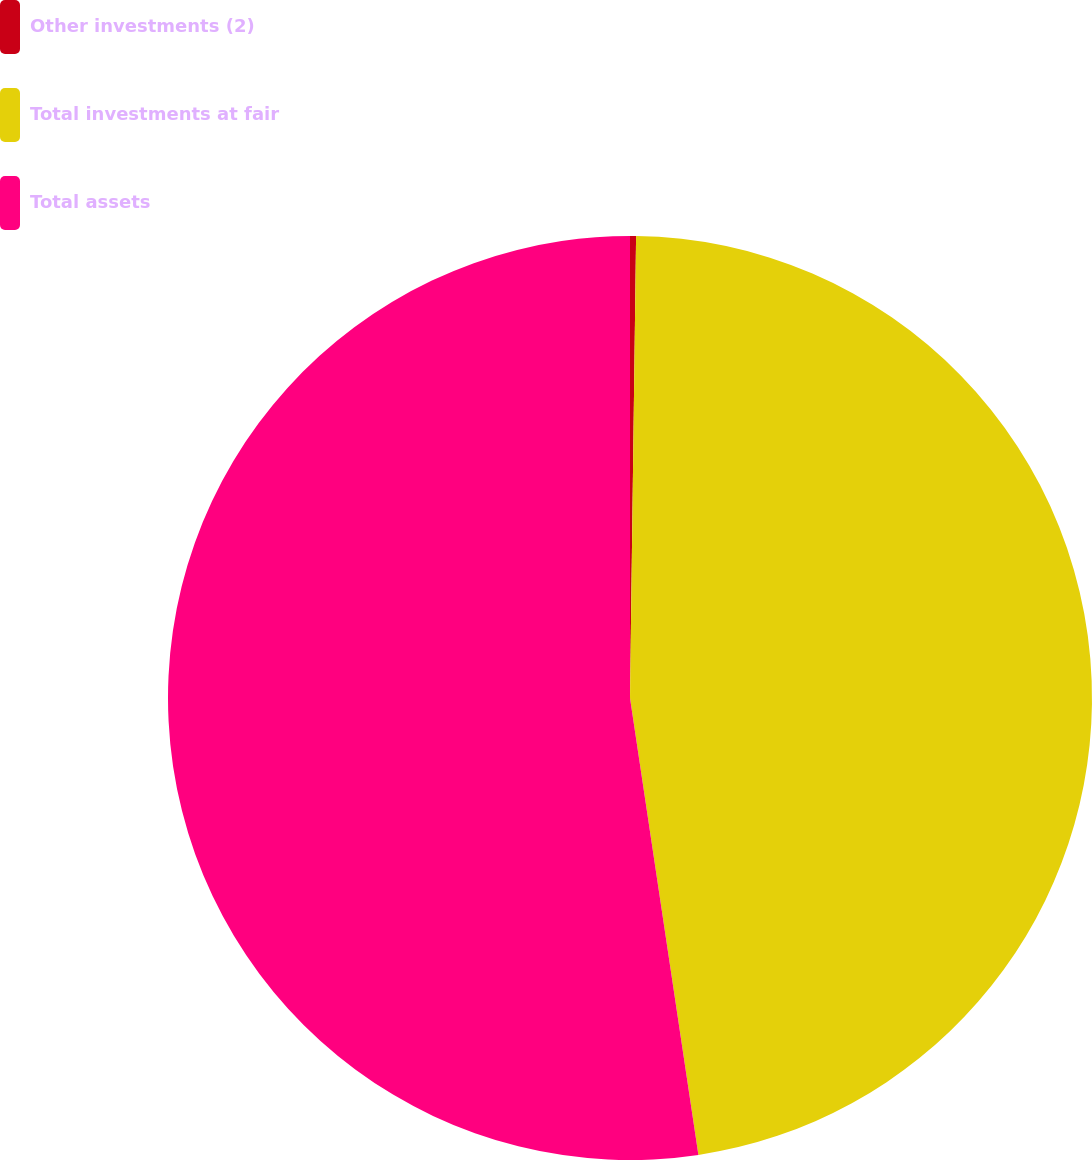Convert chart. <chart><loc_0><loc_0><loc_500><loc_500><pie_chart><fcel>Other investments (2)<fcel>Total investments at fair<fcel>Total assets<nl><fcel>0.21%<fcel>47.42%<fcel>52.36%<nl></chart> 